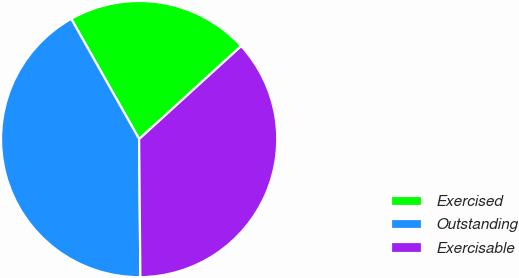<chart> <loc_0><loc_0><loc_500><loc_500><pie_chart><fcel>Exercised<fcel>Outstanding<fcel>Exercisable<nl><fcel>21.42%<fcel>41.96%<fcel>36.62%<nl></chart> 